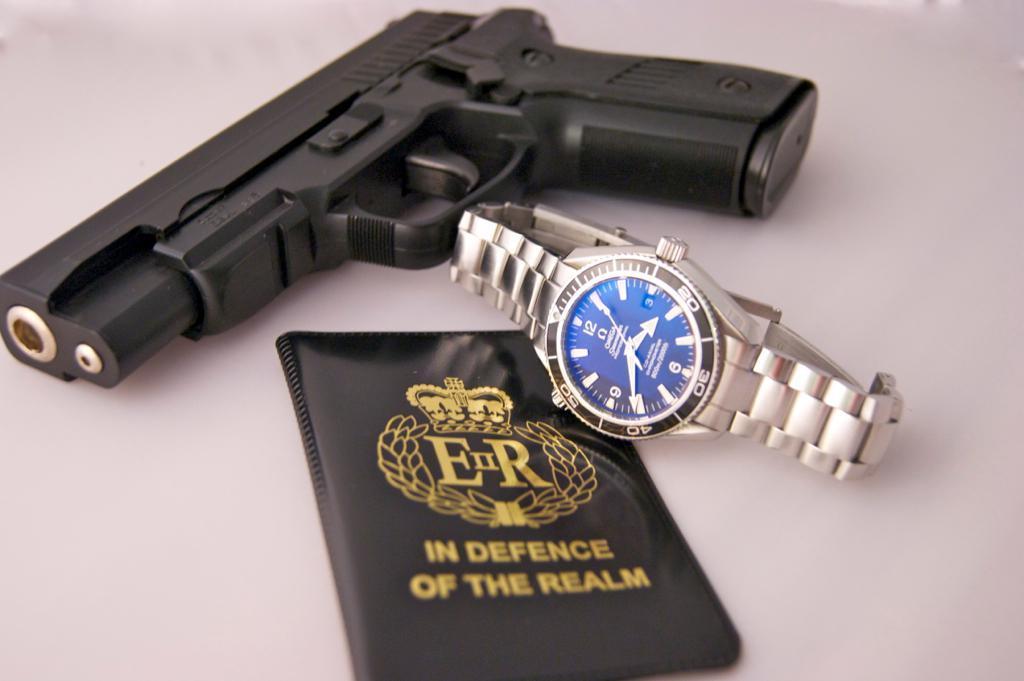Can you describe this image briefly? On the table we can see black color gun, watch and passport. 